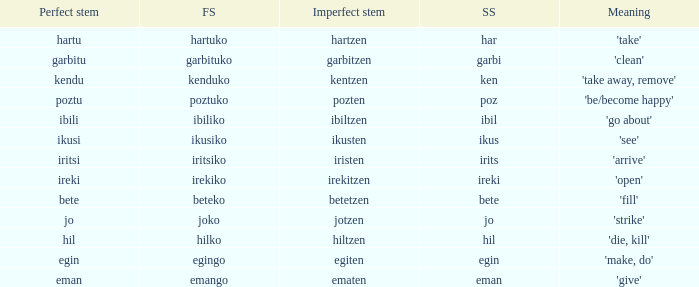Name the perfect stem for jo 1.0. 